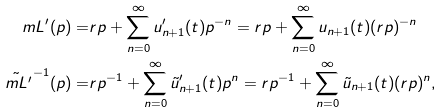Convert formula to latex. <formula><loc_0><loc_0><loc_500><loc_500>\ m L ^ { \prime } ( p ) = & r p + \sum _ { n = 0 } ^ { \infty } u ^ { \prime } _ { n + 1 } ( t ) p ^ { - n } = r p + \sum _ { n = 0 } ^ { \infty } u _ { n + 1 } ( t ) ( r p ) ^ { - n } \\ \tilde { \ m L ^ { \prime } } ^ { - 1 } ( p ) = & r p ^ { - 1 } + \sum _ { n = 0 } ^ { \infty } \tilde { u } ^ { \prime } _ { n + 1 } ( t ) p ^ { n } = r p ^ { - 1 } + \sum _ { n = 0 } ^ { \infty } \tilde { u } _ { n + 1 } ( t ) ( r p ) ^ { n } ,</formula> 